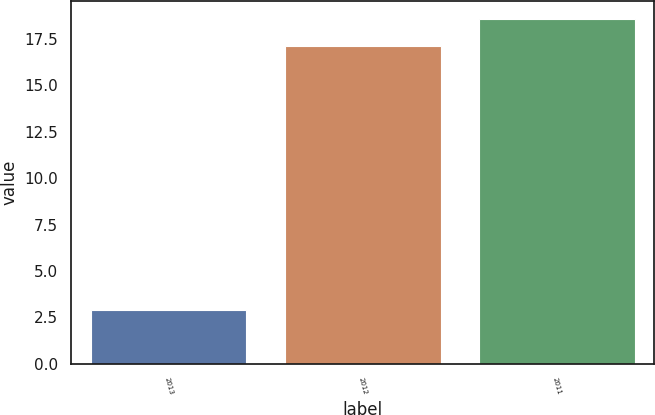Convert chart to OTSL. <chart><loc_0><loc_0><loc_500><loc_500><bar_chart><fcel>2013<fcel>2012<fcel>2011<nl><fcel>2.9<fcel>17.1<fcel>18.58<nl></chart> 